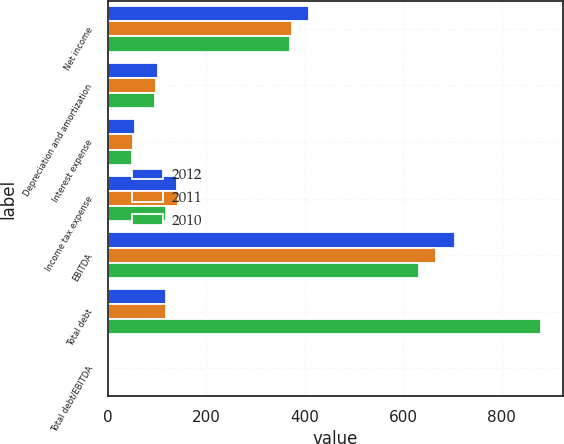<chart> <loc_0><loc_0><loc_500><loc_500><stacked_bar_chart><ecel><fcel>Net income<fcel>Depreciation and amortization<fcel>Interest expense<fcel>Income tax expense<fcel>EBITDA<fcel>Total debt<fcel>Total debt/EBITDA<nl><fcel>2012<fcel>407.8<fcel>102.8<fcel>54.6<fcel>139.8<fcel>705<fcel>118<fcel>1.66<nl><fcel>2011<fcel>374.2<fcel>98.3<fcel>51.2<fcel>142.6<fcel>666.3<fcel>118<fcel>1.88<nl><fcel>2010<fcel>370.2<fcel>95.1<fcel>49.3<fcel>118<fcel>632.6<fcel>880.3<fcel>1.39<nl></chart> 